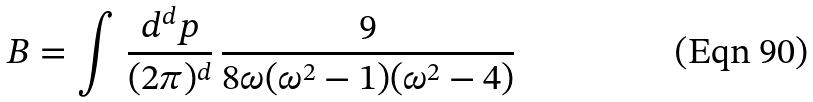Convert formula to latex. <formula><loc_0><loc_0><loc_500><loc_500>B = \int \, { \frac { d ^ { d } { p } } { ( 2 \pi ) ^ { d } } } \, { \frac { 9 } { 8 \omega ( \omega ^ { 2 } - 1 ) ( \omega ^ { 2 } - 4 ) } }</formula> 